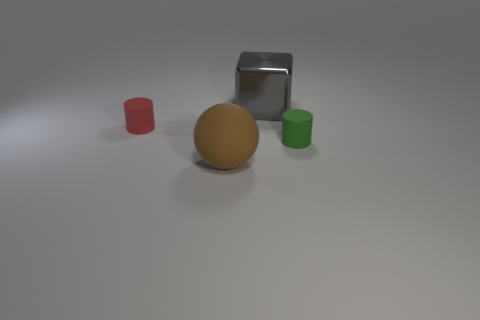What number of blocks are big rubber things or tiny red things?
Provide a short and direct response. 0. What size is the green rubber thing to the right of the rubber cylinder that is behind the green matte thing that is in front of the red matte thing?
Provide a succinct answer. Small. The rubber thing that is both on the left side of the green thing and in front of the tiny red rubber cylinder is what color?
Your response must be concise. Brown. There is a block; is it the same size as the rubber cylinder in front of the red cylinder?
Ensure brevity in your answer.  No. Are there any other things that have the same shape as the large brown thing?
Offer a terse response. No. What is the color of the other matte thing that is the same shape as the small red thing?
Your response must be concise. Green. Does the red rubber object have the same size as the gray metallic cube?
Provide a succinct answer. No. How many other things are the same size as the red object?
Your answer should be very brief. 1. How many things are rubber things in front of the tiny red cylinder or tiny objects that are on the left side of the big gray shiny block?
Ensure brevity in your answer.  3. What shape is the brown object that is the same size as the gray metallic thing?
Your response must be concise. Sphere. 